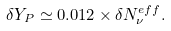<formula> <loc_0><loc_0><loc_500><loc_500>\delta Y _ { P } \simeq 0 . 0 1 2 \times \delta N _ { \nu } ^ { e f f } .</formula> 